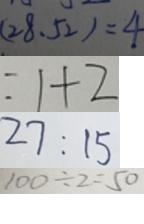Convert formula to latex. <formula><loc_0><loc_0><loc_500><loc_500>( 2 8 、 5 2 ) = 4 
 = 1 + 2 
 2 7 : 1 5 
 1 0 0 \div 2 = 5 0</formula> 